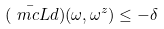Convert formula to latex. <formula><loc_0><loc_0><loc_500><loc_500>( { \bar { \ m c L } } d ) ( \omega , \omega ^ { z } ) \leq - \delta</formula> 